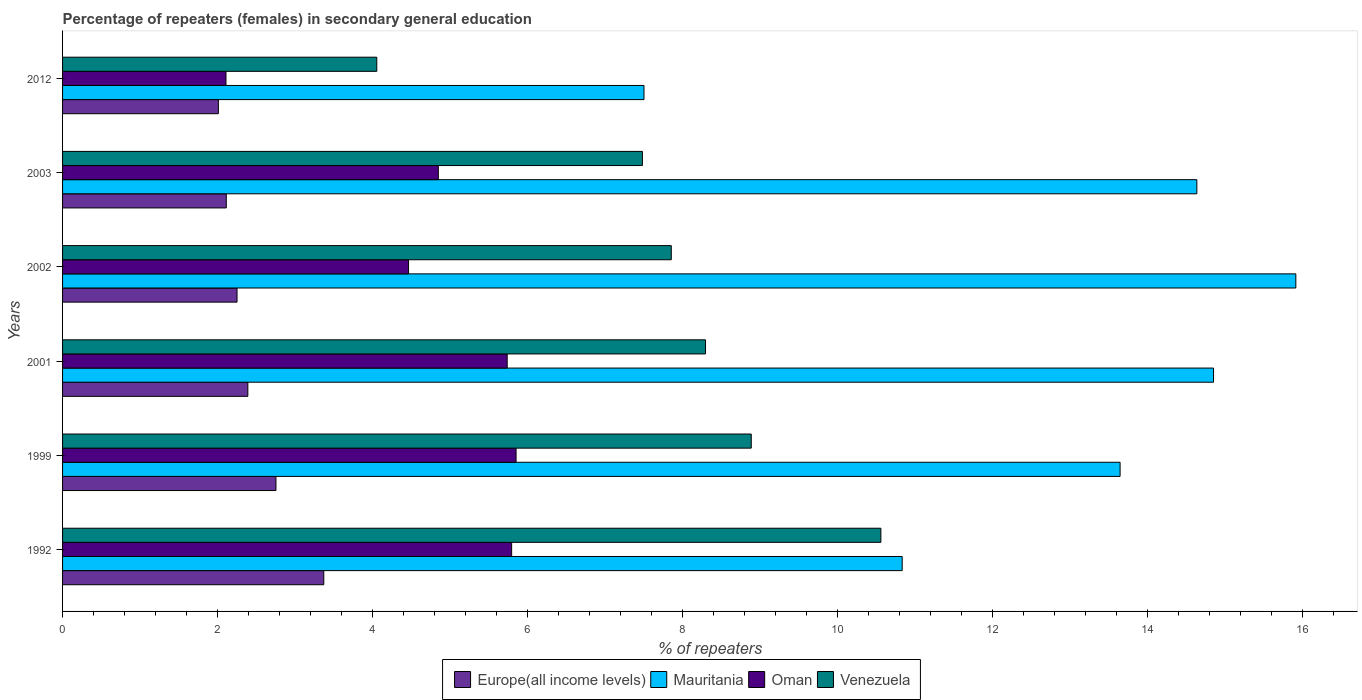How many different coloured bars are there?
Offer a very short reply. 4. How many bars are there on the 1st tick from the top?
Make the answer very short. 4. How many bars are there on the 5th tick from the bottom?
Provide a succinct answer. 4. What is the label of the 6th group of bars from the top?
Offer a very short reply. 1992. In how many cases, is the number of bars for a given year not equal to the number of legend labels?
Your answer should be compact. 0. What is the percentage of female repeaters in Venezuela in 1999?
Make the answer very short. 8.89. Across all years, what is the maximum percentage of female repeaters in Venezuela?
Your answer should be very brief. 10.56. Across all years, what is the minimum percentage of female repeaters in Europe(all income levels)?
Provide a succinct answer. 2.01. What is the total percentage of female repeaters in Europe(all income levels) in the graph?
Ensure brevity in your answer.  14.89. What is the difference between the percentage of female repeaters in Europe(all income levels) in 1992 and that in 2003?
Provide a short and direct response. 1.26. What is the difference between the percentage of female repeaters in Oman in 1992 and the percentage of female repeaters in Europe(all income levels) in 2012?
Your answer should be compact. 3.78. What is the average percentage of female repeaters in Mauritania per year?
Your response must be concise. 12.9. In the year 2003, what is the difference between the percentage of female repeaters in Europe(all income levels) and percentage of female repeaters in Venezuela?
Ensure brevity in your answer.  -5.37. What is the ratio of the percentage of female repeaters in Venezuela in 1992 to that in 2001?
Ensure brevity in your answer.  1.27. What is the difference between the highest and the second highest percentage of female repeaters in Oman?
Provide a succinct answer. 0.06. What is the difference between the highest and the lowest percentage of female repeaters in Oman?
Offer a very short reply. 3.74. Is the sum of the percentage of female repeaters in Oman in 2002 and 2012 greater than the maximum percentage of female repeaters in Venezuela across all years?
Your answer should be compact. No. Is it the case that in every year, the sum of the percentage of female repeaters in Oman and percentage of female repeaters in Mauritania is greater than the sum of percentage of female repeaters in Europe(all income levels) and percentage of female repeaters in Venezuela?
Offer a terse response. No. What does the 4th bar from the top in 1992 represents?
Provide a short and direct response. Europe(all income levels). What does the 3rd bar from the bottom in 1999 represents?
Provide a succinct answer. Oman. Are all the bars in the graph horizontal?
Give a very brief answer. Yes. What is the difference between two consecutive major ticks on the X-axis?
Offer a very short reply. 2. Are the values on the major ticks of X-axis written in scientific E-notation?
Your answer should be compact. No. Where does the legend appear in the graph?
Keep it short and to the point. Bottom center. What is the title of the graph?
Your answer should be compact. Percentage of repeaters (females) in secondary general education. What is the label or title of the X-axis?
Your answer should be very brief. % of repeaters. What is the label or title of the Y-axis?
Your answer should be very brief. Years. What is the % of repeaters of Europe(all income levels) in 1992?
Offer a very short reply. 3.37. What is the % of repeaters of Mauritania in 1992?
Offer a terse response. 10.83. What is the % of repeaters in Oman in 1992?
Give a very brief answer. 5.79. What is the % of repeaters of Venezuela in 1992?
Your answer should be compact. 10.56. What is the % of repeaters in Europe(all income levels) in 1999?
Your answer should be compact. 2.75. What is the % of repeaters of Mauritania in 1999?
Offer a very short reply. 13.64. What is the % of repeaters of Oman in 1999?
Offer a very short reply. 5.85. What is the % of repeaters in Venezuela in 1999?
Your response must be concise. 8.89. What is the % of repeaters of Europe(all income levels) in 2001?
Keep it short and to the point. 2.39. What is the % of repeaters in Mauritania in 2001?
Your response must be concise. 14.85. What is the % of repeaters in Oman in 2001?
Your answer should be very brief. 5.74. What is the % of repeaters of Venezuela in 2001?
Your answer should be compact. 8.3. What is the % of repeaters in Europe(all income levels) in 2002?
Your answer should be compact. 2.25. What is the % of repeaters of Mauritania in 2002?
Provide a short and direct response. 15.91. What is the % of repeaters in Oman in 2002?
Your answer should be very brief. 4.46. What is the % of repeaters in Venezuela in 2002?
Ensure brevity in your answer.  7.85. What is the % of repeaters of Europe(all income levels) in 2003?
Ensure brevity in your answer.  2.11. What is the % of repeaters of Mauritania in 2003?
Offer a terse response. 14.64. What is the % of repeaters in Oman in 2003?
Your answer should be compact. 4.85. What is the % of repeaters in Venezuela in 2003?
Give a very brief answer. 7.48. What is the % of repeaters in Europe(all income levels) in 2012?
Ensure brevity in your answer.  2.01. What is the % of repeaters of Mauritania in 2012?
Give a very brief answer. 7.5. What is the % of repeaters in Oman in 2012?
Give a very brief answer. 2.11. What is the % of repeaters in Venezuela in 2012?
Your answer should be very brief. 4.05. Across all years, what is the maximum % of repeaters of Europe(all income levels)?
Your answer should be very brief. 3.37. Across all years, what is the maximum % of repeaters of Mauritania?
Offer a terse response. 15.91. Across all years, what is the maximum % of repeaters of Oman?
Make the answer very short. 5.85. Across all years, what is the maximum % of repeaters of Venezuela?
Ensure brevity in your answer.  10.56. Across all years, what is the minimum % of repeaters of Europe(all income levels)?
Your answer should be compact. 2.01. Across all years, what is the minimum % of repeaters in Mauritania?
Make the answer very short. 7.5. Across all years, what is the minimum % of repeaters in Oman?
Your answer should be compact. 2.11. Across all years, what is the minimum % of repeaters in Venezuela?
Your response must be concise. 4.05. What is the total % of repeaters of Europe(all income levels) in the graph?
Keep it short and to the point. 14.89. What is the total % of repeaters of Mauritania in the graph?
Your response must be concise. 77.38. What is the total % of repeaters of Oman in the graph?
Make the answer very short. 28.8. What is the total % of repeaters in Venezuela in the graph?
Your response must be concise. 47.13. What is the difference between the % of repeaters of Europe(all income levels) in 1992 and that in 1999?
Make the answer very short. 0.62. What is the difference between the % of repeaters in Mauritania in 1992 and that in 1999?
Provide a short and direct response. -2.81. What is the difference between the % of repeaters of Oman in 1992 and that in 1999?
Offer a terse response. -0.06. What is the difference between the % of repeaters in Venezuela in 1992 and that in 1999?
Offer a very short reply. 1.67. What is the difference between the % of repeaters of Europe(all income levels) in 1992 and that in 2001?
Keep it short and to the point. 0.98. What is the difference between the % of repeaters in Mauritania in 1992 and that in 2001?
Offer a terse response. -4.02. What is the difference between the % of repeaters of Oman in 1992 and that in 2001?
Provide a short and direct response. 0.06. What is the difference between the % of repeaters of Venezuela in 1992 and that in 2001?
Offer a very short reply. 2.26. What is the difference between the % of repeaters in Europe(all income levels) in 1992 and that in 2002?
Ensure brevity in your answer.  1.12. What is the difference between the % of repeaters of Mauritania in 1992 and that in 2002?
Provide a succinct answer. -5.08. What is the difference between the % of repeaters in Oman in 1992 and that in 2002?
Your answer should be very brief. 1.33. What is the difference between the % of repeaters in Venezuela in 1992 and that in 2002?
Offer a very short reply. 2.7. What is the difference between the % of repeaters of Europe(all income levels) in 1992 and that in 2003?
Give a very brief answer. 1.26. What is the difference between the % of repeaters of Mauritania in 1992 and that in 2003?
Your response must be concise. -3.8. What is the difference between the % of repeaters of Oman in 1992 and that in 2003?
Offer a very short reply. 0.95. What is the difference between the % of repeaters of Venezuela in 1992 and that in 2003?
Provide a succinct answer. 3.08. What is the difference between the % of repeaters of Europe(all income levels) in 1992 and that in 2012?
Your answer should be very brief. 1.36. What is the difference between the % of repeaters of Mauritania in 1992 and that in 2012?
Offer a terse response. 3.33. What is the difference between the % of repeaters of Oman in 1992 and that in 2012?
Make the answer very short. 3.69. What is the difference between the % of repeaters in Venezuela in 1992 and that in 2012?
Keep it short and to the point. 6.5. What is the difference between the % of repeaters of Europe(all income levels) in 1999 and that in 2001?
Keep it short and to the point. 0.36. What is the difference between the % of repeaters of Mauritania in 1999 and that in 2001?
Keep it short and to the point. -1.21. What is the difference between the % of repeaters of Oman in 1999 and that in 2001?
Give a very brief answer. 0.11. What is the difference between the % of repeaters in Venezuela in 1999 and that in 2001?
Ensure brevity in your answer.  0.59. What is the difference between the % of repeaters in Europe(all income levels) in 1999 and that in 2002?
Make the answer very short. 0.5. What is the difference between the % of repeaters of Mauritania in 1999 and that in 2002?
Make the answer very short. -2.27. What is the difference between the % of repeaters of Oman in 1999 and that in 2002?
Make the answer very short. 1.39. What is the difference between the % of repeaters of Venezuela in 1999 and that in 2002?
Make the answer very short. 1.03. What is the difference between the % of repeaters in Europe(all income levels) in 1999 and that in 2003?
Provide a short and direct response. 0.64. What is the difference between the % of repeaters of Mauritania in 1999 and that in 2003?
Provide a short and direct response. -0.99. What is the difference between the % of repeaters of Oman in 1999 and that in 2003?
Offer a terse response. 1. What is the difference between the % of repeaters in Venezuela in 1999 and that in 2003?
Provide a short and direct response. 1.4. What is the difference between the % of repeaters of Europe(all income levels) in 1999 and that in 2012?
Provide a short and direct response. 0.74. What is the difference between the % of repeaters in Mauritania in 1999 and that in 2012?
Give a very brief answer. 6.14. What is the difference between the % of repeaters in Oman in 1999 and that in 2012?
Make the answer very short. 3.74. What is the difference between the % of repeaters of Venezuela in 1999 and that in 2012?
Your answer should be compact. 4.83. What is the difference between the % of repeaters of Europe(all income levels) in 2001 and that in 2002?
Provide a succinct answer. 0.14. What is the difference between the % of repeaters of Mauritania in 2001 and that in 2002?
Provide a succinct answer. -1.06. What is the difference between the % of repeaters of Oman in 2001 and that in 2002?
Provide a short and direct response. 1.27. What is the difference between the % of repeaters in Venezuela in 2001 and that in 2002?
Provide a succinct answer. 0.44. What is the difference between the % of repeaters in Europe(all income levels) in 2001 and that in 2003?
Provide a succinct answer. 0.28. What is the difference between the % of repeaters of Mauritania in 2001 and that in 2003?
Your answer should be very brief. 0.22. What is the difference between the % of repeaters in Oman in 2001 and that in 2003?
Provide a succinct answer. 0.89. What is the difference between the % of repeaters in Venezuela in 2001 and that in 2003?
Provide a succinct answer. 0.81. What is the difference between the % of repeaters of Europe(all income levels) in 2001 and that in 2012?
Your answer should be compact. 0.38. What is the difference between the % of repeaters of Mauritania in 2001 and that in 2012?
Keep it short and to the point. 7.35. What is the difference between the % of repeaters of Oman in 2001 and that in 2012?
Make the answer very short. 3.63. What is the difference between the % of repeaters of Venezuela in 2001 and that in 2012?
Provide a succinct answer. 4.24. What is the difference between the % of repeaters in Europe(all income levels) in 2002 and that in 2003?
Provide a succinct answer. 0.14. What is the difference between the % of repeaters of Mauritania in 2002 and that in 2003?
Offer a terse response. 1.28. What is the difference between the % of repeaters in Oman in 2002 and that in 2003?
Provide a succinct answer. -0.38. What is the difference between the % of repeaters of Venezuela in 2002 and that in 2003?
Provide a short and direct response. 0.37. What is the difference between the % of repeaters of Europe(all income levels) in 2002 and that in 2012?
Make the answer very short. 0.24. What is the difference between the % of repeaters in Mauritania in 2002 and that in 2012?
Provide a succinct answer. 8.41. What is the difference between the % of repeaters in Oman in 2002 and that in 2012?
Offer a very short reply. 2.36. What is the difference between the % of repeaters of Venezuela in 2002 and that in 2012?
Your response must be concise. 3.8. What is the difference between the % of repeaters in Europe(all income levels) in 2003 and that in 2012?
Your answer should be compact. 0.1. What is the difference between the % of repeaters of Mauritania in 2003 and that in 2012?
Provide a succinct answer. 7.13. What is the difference between the % of repeaters in Oman in 2003 and that in 2012?
Your answer should be compact. 2.74. What is the difference between the % of repeaters of Venezuela in 2003 and that in 2012?
Offer a terse response. 3.43. What is the difference between the % of repeaters in Europe(all income levels) in 1992 and the % of repeaters in Mauritania in 1999?
Offer a terse response. -10.27. What is the difference between the % of repeaters of Europe(all income levels) in 1992 and the % of repeaters of Oman in 1999?
Give a very brief answer. -2.48. What is the difference between the % of repeaters in Europe(all income levels) in 1992 and the % of repeaters in Venezuela in 1999?
Ensure brevity in your answer.  -5.52. What is the difference between the % of repeaters in Mauritania in 1992 and the % of repeaters in Oman in 1999?
Provide a short and direct response. 4.98. What is the difference between the % of repeaters in Mauritania in 1992 and the % of repeaters in Venezuela in 1999?
Provide a succinct answer. 1.95. What is the difference between the % of repeaters in Oman in 1992 and the % of repeaters in Venezuela in 1999?
Ensure brevity in your answer.  -3.09. What is the difference between the % of repeaters of Europe(all income levels) in 1992 and the % of repeaters of Mauritania in 2001?
Provide a succinct answer. -11.48. What is the difference between the % of repeaters of Europe(all income levels) in 1992 and the % of repeaters of Oman in 2001?
Provide a short and direct response. -2.37. What is the difference between the % of repeaters of Europe(all income levels) in 1992 and the % of repeaters of Venezuela in 2001?
Your response must be concise. -4.93. What is the difference between the % of repeaters of Mauritania in 1992 and the % of repeaters of Oman in 2001?
Ensure brevity in your answer.  5.1. What is the difference between the % of repeaters in Mauritania in 1992 and the % of repeaters in Venezuela in 2001?
Offer a terse response. 2.54. What is the difference between the % of repeaters in Oman in 1992 and the % of repeaters in Venezuela in 2001?
Ensure brevity in your answer.  -2.5. What is the difference between the % of repeaters in Europe(all income levels) in 1992 and the % of repeaters in Mauritania in 2002?
Provide a succinct answer. -12.54. What is the difference between the % of repeaters of Europe(all income levels) in 1992 and the % of repeaters of Oman in 2002?
Offer a very short reply. -1.09. What is the difference between the % of repeaters of Europe(all income levels) in 1992 and the % of repeaters of Venezuela in 2002?
Offer a very short reply. -4.48. What is the difference between the % of repeaters of Mauritania in 1992 and the % of repeaters of Oman in 2002?
Give a very brief answer. 6.37. What is the difference between the % of repeaters of Mauritania in 1992 and the % of repeaters of Venezuela in 2002?
Give a very brief answer. 2.98. What is the difference between the % of repeaters in Oman in 1992 and the % of repeaters in Venezuela in 2002?
Give a very brief answer. -2.06. What is the difference between the % of repeaters of Europe(all income levels) in 1992 and the % of repeaters of Mauritania in 2003?
Your answer should be very brief. -11.26. What is the difference between the % of repeaters of Europe(all income levels) in 1992 and the % of repeaters of Oman in 2003?
Offer a very short reply. -1.48. What is the difference between the % of repeaters in Europe(all income levels) in 1992 and the % of repeaters in Venezuela in 2003?
Keep it short and to the point. -4.11. What is the difference between the % of repeaters in Mauritania in 1992 and the % of repeaters in Oman in 2003?
Your answer should be very brief. 5.99. What is the difference between the % of repeaters of Mauritania in 1992 and the % of repeaters of Venezuela in 2003?
Provide a succinct answer. 3.35. What is the difference between the % of repeaters of Oman in 1992 and the % of repeaters of Venezuela in 2003?
Your response must be concise. -1.69. What is the difference between the % of repeaters in Europe(all income levels) in 1992 and the % of repeaters in Mauritania in 2012?
Keep it short and to the point. -4.13. What is the difference between the % of repeaters of Europe(all income levels) in 1992 and the % of repeaters of Oman in 2012?
Make the answer very short. 1.26. What is the difference between the % of repeaters in Europe(all income levels) in 1992 and the % of repeaters in Venezuela in 2012?
Your answer should be very brief. -0.68. What is the difference between the % of repeaters in Mauritania in 1992 and the % of repeaters in Oman in 2012?
Give a very brief answer. 8.72. What is the difference between the % of repeaters in Mauritania in 1992 and the % of repeaters in Venezuela in 2012?
Keep it short and to the point. 6.78. What is the difference between the % of repeaters of Oman in 1992 and the % of repeaters of Venezuela in 2012?
Provide a short and direct response. 1.74. What is the difference between the % of repeaters in Europe(all income levels) in 1999 and the % of repeaters in Mauritania in 2001?
Your answer should be compact. -12.1. What is the difference between the % of repeaters of Europe(all income levels) in 1999 and the % of repeaters of Oman in 2001?
Provide a short and direct response. -2.98. What is the difference between the % of repeaters of Europe(all income levels) in 1999 and the % of repeaters of Venezuela in 2001?
Offer a very short reply. -5.54. What is the difference between the % of repeaters of Mauritania in 1999 and the % of repeaters of Oman in 2001?
Give a very brief answer. 7.91. What is the difference between the % of repeaters of Mauritania in 1999 and the % of repeaters of Venezuela in 2001?
Offer a terse response. 5.35. What is the difference between the % of repeaters in Oman in 1999 and the % of repeaters in Venezuela in 2001?
Your answer should be very brief. -2.44. What is the difference between the % of repeaters of Europe(all income levels) in 1999 and the % of repeaters of Mauritania in 2002?
Provide a short and direct response. -13.16. What is the difference between the % of repeaters in Europe(all income levels) in 1999 and the % of repeaters in Oman in 2002?
Make the answer very short. -1.71. What is the difference between the % of repeaters in Europe(all income levels) in 1999 and the % of repeaters in Venezuela in 2002?
Offer a very short reply. -5.1. What is the difference between the % of repeaters in Mauritania in 1999 and the % of repeaters in Oman in 2002?
Your response must be concise. 9.18. What is the difference between the % of repeaters in Mauritania in 1999 and the % of repeaters in Venezuela in 2002?
Provide a short and direct response. 5.79. What is the difference between the % of repeaters of Oman in 1999 and the % of repeaters of Venezuela in 2002?
Give a very brief answer. -2. What is the difference between the % of repeaters of Europe(all income levels) in 1999 and the % of repeaters of Mauritania in 2003?
Your response must be concise. -11.88. What is the difference between the % of repeaters in Europe(all income levels) in 1999 and the % of repeaters in Oman in 2003?
Your answer should be very brief. -2.1. What is the difference between the % of repeaters of Europe(all income levels) in 1999 and the % of repeaters of Venezuela in 2003?
Provide a succinct answer. -4.73. What is the difference between the % of repeaters of Mauritania in 1999 and the % of repeaters of Oman in 2003?
Your answer should be very brief. 8.8. What is the difference between the % of repeaters of Mauritania in 1999 and the % of repeaters of Venezuela in 2003?
Give a very brief answer. 6.16. What is the difference between the % of repeaters in Oman in 1999 and the % of repeaters in Venezuela in 2003?
Give a very brief answer. -1.63. What is the difference between the % of repeaters of Europe(all income levels) in 1999 and the % of repeaters of Mauritania in 2012?
Give a very brief answer. -4.75. What is the difference between the % of repeaters in Europe(all income levels) in 1999 and the % of repeaters in Oman in 2012?
Offer a very short reply. 0.64. What is the difference between the % of repeaters of Europe(all income levels) in 1999 and the % of repeaters of Venezuela in 2012?
Keep it short and to the point. -1.3. What is the difference between the % of repeaters in Mauritania in 1999 and the % of repeaters in Oman in 2012?
Offer a very short reply. 11.54. What is the difference between the % of repeaters of Mauritania in 1999 and the % of repeaters of Venezuela in 2012?
Make the answer very short. 9.59. What is the difference between the % of repeaters of Oman in 1999 and the % of repeaters of Venezuela in 2012?
Your answer should be very brief. 1.8. What is the difference between the % of repeaters in Europe(all income levels) in 2001 and the % of repeaters in Mauritania in 2002?
Your answer should be compact. -13.52. What is the difference between the % of repeaters of Europe(all income levels) in 2001 and the % of repeaters of Oman in 2002?
Give a very brief answer. -2.07. What is the difference between the % of repeaters of Europe(all income levels) in 2001 and the % of repeaters of Venezuela in 2002?
Your response must be concise. -5.46. What is the difference between the % of repeaters in Mauritania in 2001 and the % of repeaters in Oman in 2002?
Make the answer very short. 10.39. What is the difference between the % of repeaters in Mauritania in 2001 and the % of repeaters in Venezuela in 2002?
Offer a terse response. 7. What is the difference between the % of repeaters in Oman in 2001 and the % of repeaters in Venezuela in 2002?
Your answer should be very brief. -2.12. What is the difference between the % of repeaters in Europe(all income levels) in 2001 and the % of repeaters in Mauritania in 2003?
Ensure brevity in your answer.  -12.24. What is the difference between the % of repeaters in Europe(all income levels) in 2001 and the % of repeaters in Oman in 2003?
Give a very brief answer. -2.46. What is the difference between the % of repeaters in Europe(all income levels) in 2001 and the % of repeaters in Venezuela in 2003?
Make the answer very short. -5.09. What is the difference between the % of repeaters of Mauritania in 2001 and the % of repeaters of Oman in 2003?
Provide a succinct answer. 10. What is the difference between the % of repeaters in Mauritania in 2001 and the % of repeaters in Venezuela in 2003?
Give a very brief answer. 7.37. What is the difference between the % of repeaters in Oman in 2001 and the % of repeaters in Venezuela in 2003?
Offer a very short reply. -1.74. What is the difference between the % of repeaters in Europe(all income levels) in 2001 and the % of repeaters in Mauritania in 2012?
Make the answer very short. -5.11. What is the difference between the % of repeaters of Europe(all income levels) in 2001 and the % of repeaters of Oman in 2012?
Your answer should be very brief. 0.28. What is the difference between the % of repeaters in Europe(all income levels) in 2001 and the % of repeaters in Venezuela in 2012?
Offer a terse response. -1.66. What is the difference between the % of repeaters of Mauritania in 2001 and the % of repeaters of Oman in 2012?
Ensure brevity in your answer.  12.74. What is the difference between the % of repeaters in Mauritania in 2001 and the % of repeaters in Venezuela in 2012?
Offer a very short reply. 10.8. What is the difference between the % of repeaters in Oman in 2001 and the % of repeaters in Venezuela in 2012?
Your answer should be compact. 1.68. What is the difference between the % of repeaters in Europe(all income levels) in 2002 and the % of repeaters in Mauritania in 2003?
Offer a very short reply. -12.38. What is the difference between the % of repeaters in Europe(all income levels) in 2002 and the % of repeaters in Oman in 2003?
Ensure brevity in your answer.  -2.6. What is the difference between the % of repeaters in Europe(all income levels) in 2002 and the % of repeaters in Venezuela in 2003?
Keep it short and to the point. -5.23. What is the difference between the % of repeaters of Mauritania in 2002 and the % of repeaters of Oman in 2003?
Ensure brevity in your answer.  11.06. What is the difference between the % of repeaters of Mauritania in 2002 and the % of repeaters of Venezuela in 2003?
Provide a short and direct response. 8.43. What is the difference between the % of repeaters in Oman in 2002 and the % of repeaters in Venezuela in 2003?
Your answer should be compact. -3.02. What is the difference between the % of repeaters in Europe(all income levels) in 2002 and the % of repeaters in Mauritania in 2012?
Your answer should be very brief. -5.25. What is the difference between the % of repeaters of Europe(all income levels) in 2002 and the % of repeaters of Oman in 2012?
Give a very brief answer. 0.14. What is the difference between the % of repeaters of Europe(all income levels) in 2002 and the % of repeaters of Venezuela in 2012?
Provide a succinct answer. -1.8. What is the difference between the % of repeaters in Mauritania in 2002 and the % of repeaters in Oman in 2012?
Keep it short and to the point. 13.8. What is the difference between the % of repeaters of Mauritania in 2002 and the % of repeaters of Venezuela in 2012?
Offer a terse response. 11.86. What is the difference between the % of repeaters in Oman in 2002 and the % of repeaters in Venezuela in 2012?
Your response must be concise. 0.41. What is the difference between the % of repeaters of Europe(all income levels) in 2003 and the % of repeaters of Mauritania in 2012?
Provide a succinct answer. -5.39. What is the difference between the % of repeaters of Europe(all income levels) in 2003 and the % of repeaters of Oman in 2012?
Provide a short and direct response. 0. What is the difference between the % of repeaters of Europe(all income levels) in 2003 and the % of repeaters of Venezuela in 2012?
Provide a succinct answer. -1.94. What is the difference between the % of repeaters in Mauritania in 2003 and the % of repeaters in Oman in 2012?
Offer a very short reply. 12.53. What is the difference between the % of repeaters of Mauritania in 2003 and the % of repeaters of Venezuela in 2012?
Your response must be concise. 10.58. What is the difference between the % of repeaters of Oman in 2003 and the % of repeaters of Venezuela in 2012?
Make the answer very short. 0.79. What is the average % of repeaters of Europe(all income levels) per year?
Your response must be concise. 2.48. What is the average % of repeaters of Mauritania per year?
Ensure brevity in your answer.  12.9. What is the average % of repeaters in Oman per year?
Your answer should be very brief. 4.8. What is the average % of repeaters in Venezuela per year?
Your response must be concise. 7.86. In the year 1992, what is the difference between the % of repeaters in Europe(all income levels) and % of repeaters in Mauritania?
Your answer should be very brief. -7.46. In the year 1992, what is the difference between the % of repeaters in Europe(all income levels) and % of repeaters in Oman?
Make the answer very short. -2.42. In the year 1992, what is the difference between the % of repeaters of Europe(all income levels) and % of repeaters of Venezuela?
Provide a succinct answer. -7.19. In the year 1992, what is the difference between the % of repeaters of Mauritania and % of repeaters of Oman?
Give a very brief answer. 5.04. In the year 1992, what is the difference between the % of repeaters of Mauritania and % of repeaters of Venezuela?
Provide a short and direct response. 0.28. In the year 1992, what is the difference between the % of repeaters in Oman and % of repeaters in Venezuela?
Provide a short and direct response. -4.76. In the year 1999, what is the difference between the % of repeaters of Europe(all income levels) and % of repeaters of Mauritania?
Provide a succinct answer. -10.89. In the year 1999, what is the difference between the % of repeaters of Europe(all income levels) and % of repeaters of Oman?
Provide a short and direct response. -3.1. In the year 1999, what is the difference between the % of repeaters of Europe(all income levels) and % of repeaters of Venezuela?
Give a very brief answer. -6.13. In the year 1999, what is the difference between the % of repeaters of Mauritania and % of repeaters of Oman?
Your answer should be very brief. 7.79. In the year 1999, what is the difference between the % of repeaters of Mauritania and % of repeaters of Venezuela?
Your response must be concise. 4.76. In the year 1999, what is the difference between the % of repeaters of Oman and % of repeaters of Venezuela?
Keep it short and to the point. -3.03. In the year 2001, what is the difference between the % of repeaters of Europe(all income levels) and % of repeaters of Mauritania?
Provide a succinct answer. -12.46. In the year 2001, what is the difference between the % of repeaters in Europe(all income levels) and % of repeaters in Oman?
Ensure brevity in your answer.  -3.35. In the year 2001, what is the difference between the % of repeaters of Europe(all income levels) and % of repeaters of Venezuela?
Provide a short and direct response. -5.91. In the year 2001, what is the difference between the % of repeaters of Mauritania and % of repeaters of Oman?
Keep it short and to the point. 9.11. In the year 2001, what is the difference between the % of repeaters in Mauritania and % of repeaters in Venezuela?
Offer a very short reply. 6.55. In the year 2001, what is the difference between the % of repeaters in Oman and % of repeaters in Venezuela?
Keep it short and to the point. -2.56. In the year 2002, what is the difference between the % of repeaters of Europe(all income levels) and % of repeaters of Mauritania?
Your answer should be very brief. -13.66. In the year 2002, what is the difference between the % of repeaters in Europe(all income levels) and % of repeaters in Oman?
Your answer should be compact. -2.21. In the year 2002, what is the difference between the % of repeaters in Europe(all income levels) and % of repeaters in Venezuela?
Keep it short and to the point. -5.6. In the year 2002, what is the difference between the % of repeaters of Mauritania and % of repeaters of Oman?
Ensure brevity in your answer.  11.45. In the year 2002, what is the difference between the % of repeaters of Mauritania and % of repeaters of Venezuela?
Give a very brief answer. 8.06. In the year 2002, what is the difference between the % of repeaters in Oman and % of repeaters in Venezuela?
Ensure brevity in your answer.  -3.39. In the year 2003, what is the difference between the % of repeaters in Europe(all income levels) and % of repeaters in Mauritania?
Provide a succinct answer. -12.52. In the year 2003, what is the difference between the % of repeaters of Europe(all income levels) and % of repeaters of Oman?
Provide a succinct answer. -2.74. In the year 2003, what is the difference between the % of repeaters in Europe(all income levels) and % of repeaters in Venezuela?
Offer a very short reply. -5.37. In the year 2003, what is the difference between the % of repeaters in Mauritania and % of repeaters in Oman?
Ensure brevity in your answer.  9.79. In the year 2003, what is the difference between the % of repeaters in Mauritania and % of repeaters in Venezuela?
Offer a terse response. 7.15. In the year 2003, what is the difference between the % of repeaters in Oman and % of repeaters in Venezuela?
Offer a terse response. -2.63. In the year 2012, what is the difference between the % of repeaters of Europe(all income levels) and % of repeaters of Mauritania?
Provide a succinct answer. -5.49. In the year 2012, what is the difference between the % of repeaters in Europe(all income levels) and % of repeaters in Oman?
Your response must be concise. -0.1. In the year 2012, what is the difference between the % of repeaters of Europe(all income levels) and % of repeaters of Venezuela?
Your answer should be compact. -2.04. In the year 2012, what is the difference between the % of repeaters in Mauritania and % of repeaters in Oman?
Offer a terse response. 5.39. In the year 2012, what is the difference between the % of repeaters in Mauritania and % of repeaters in Venezuela?
Give a very brief answer. 3.45. In the year 2012, what is the difference between the % of repeaters in Oman and % of repeaters in Venezuela?
Your answer should be very brief. -1.95. What is the ratio of the % of repeaters in Europe(all income levels) in 1992 to that in 1999?
Keep it short and to the point. 1.22. What is the ratio of the % of repeaters of Mauritania in 1992 to that in 1999?
Offer a terse response. 0.79. What is the ratio of the % of repeaters in Oman in 1992 to that in 1999?
Ensure brevity in your answer.  0.99. What is the ratio of the % of repeaters of Venezuela in 1992 to that in 1999?
Make the answer very short. 1.19. What is the ratio of the % of repeaters in Europe(all income levels) in 1992 to that in 2001?
Ensure brevity in your answer.  1.41. What is the ratio of the % of repeaters of Mauritania in 1992 to that in 2001?
Give a very brief answer. 0.73. What is the ratio of the % of repeaters in Oman in 1992 to that in 2001?
Offer a very short reply. 1.01. What is the ratio of the % of repeaters in Venezuela in 1992 to that in 2001?
Offer a terse response. 1.27. What is the ratio of the % of repeaters in Europe(all income levels) in 1992 to that in 2002?
Make the answer very short. 1.5. What is the ratio of the % of repeaters of Mauritania in 1992 to that in 2002?
Your answer should be compact. 0.68. What is the ratio of the % of repeaters in Oman in 1992 to that in 2002?
Ensure brevity in your answer.  1.3. What is the ratio of the % of repeaters in Venezuela in 1992 to that in 2002?
Provide a succinct answer. 1.34. What is the ratio of the % of repeaters of Europe(all income levels) in 1992 to that in 2003?
Provide a succinct answer. 1.6. What is the ratio of the % of repeaters of Mauritania in 1992 to that in 2003?
Ensure brevity in your answer.  0.74. What is the ratio of the % of repeaters of Oman in 1992 to that in 2003?
Your response must be concise. 1.2. What is the ratio of the % of repeaters of Venezuela in 1992 to that in 2003?
Provide a succinct answer. 1.41. What is the ratio of the % of repeaters of Europe(all income levels) in 1992 to that in 2012?
Provide a short and direct response. 1.68. What is the ratio of the % of repeaters in Mauritania in 1992 to that in 2012?
Give a very brief answer. 1.44. What is the ratio of the % of repeaters in Oman in 1992 to that in 2012?
Provide a succinct answer. 2.75. What is the ratio of the % of repeaters in Venezuela in 1992 to that in 2012?
Make the answer very short. 2.6. What is the ratio of the % of repeaters of Europe(all income levels) in 1999 to that in 2001?
Your response must be concise. 1.15. What is the ratio of the % of repeaters of Mauritania in 1999 to that in 2001?
Your answer should be compact. 0.92. What is the ratio of the % of repeaters in Oman in 1999 to that in 2001?
Provide a succinct answer. 1.02. What is the ratio of the % of repeaters of Venezuela in 1999 to that in 2001?
Give a very brief answer. 1.07. What is the ratio of the % of repeaters in Europe(all income levels) in 1999 to that in 2002?
Provide a short and direct response. 1.22. What is the ratio of the % of repeaters in Mauritania in 1999 to that in 2002?
Make the answer very short. 0.86. What is the ratio of the % of repeaters of Oman in 1999 to that in 2002?
Provide a short and direct response. 1.31. What is the ratio of the % of repeaters of Venezuela in 1999 to that in 2002?
Your answer should be very brief. 1.13. What is the ratio of the % of repeaters of Europe(all income levels) in 1999 to that in 2003?
Offer a very short reply. 1.3. What is the ratio of the % of repeaters of Mauritania in 1999 to that in 2003?
Ensure brevity in your answer.  0.93. What is the ratio of the % of repeaters in Oman in 1999 to that in 2003?
Offer a very short reply. 1.21. What is the ratio of the % of repeaters in Venezuela in 1999 to that in 2003?
Offer a terse response. 1.19. What is the ratio of the % of repeaters in Europe(all income levels) in 1999 to that in 2012?
Offer a very short reply. 1.37. What is the ratio of the % of repeaters in Mauritania in 1999 to that in 2012?
Provide a short and direct response. 1.82. What is the ratio of the % of repeaters in Oman in 1999 to that in 2012?
Your answer should be very brief. 2.78. What is the ratio of the % of repeaters in Venezuela in 1999 to that in 2012?
Your response must be concise. 2.19. What is the ratio of the % of repeaters of Europe(all income levels) in 2001 to that in 2002?
Your answer should be very brief. 1.06. What is the ratio of the % of repeaters in Oman in 2001 to that in 2002?
Offer a terse response. 1.29. What is the ratio of the % of repeaters of Venezuela in 2001 to that in 2002?
Your answer should be very brief. 1.06. What is the ratio of the % of repeaters of Europe(all income levels) in 2001 to that in 2003?
Provide a succinct answer. 1.13. What is the ratio of the % of repeaters in Mauritania in 2001 to that in 2003?
Keep it short and to the point. 1.01. What is the ratio of the % of repeaters in Oman in 2001 to that in 2003?
Your response must be concise. 1.18. What is the ratio of the % of repeaters in Venezuela in 2001 to that in 2003?
Provide a short and direct response. 1.11. What is the ratio of the % of repeaters in Europe(all income levels) in 2001 to that in 2012?
Your answer should be very brief. 1.19. What is the ratio of the % of repeaters in Mauritania in 2001 to that in 2012?
Provide a short and direct response. 1.98. What is the ratio of the % of repeaters of Oman in 2001 to that in 2012?
Keep it short and to the point. 2.72. What is the ratio of the % of repeaters of Venezuela in 2001 to that in 2012?
Keep it short and to the point. 2.05. What is the ratio of the % of repeaters in Europe(all income levels) in 2002 to that in 2003?
Offer a terse response. 1.07. What is the ratio of the % of repeaters of Mauritania in 2002 to that in 2003?
Provide a succinct answer. 1.09. What is the ratio of the % of repeaters in Oman in 2002 to that in 2003?
Give a very brief answer. 0.92. What is the ratio of the % of repeaters of Venezuela in 2002 to that in 2003?
Your response must be concise. 1.05. What is the ratio of the % of repeaters in Europe(all income levels) in 2002 to that in 2012?
Your answer should be very brief. 1.12. What is the ratio of the % of repeaters of Mauritania in 2002 to that in 2012?
Your answer should be very brief. 2.12. What is the ratio of the % of repeaters of Oman in 2002 to that in 2012?
Your answer should be very brief. 2.12. What is the ratio of the % of repeaters in Venezuela in 2002 to that in 2012?
Provide a succinct answer. 1.94. What is the ratio of the % of repeaters in Europe(all income levels) in 2003 to that in 2012?
Make the answer very short. 1.05. What is the ratio of the % of repeaters in Mauritania in 2003 to that in 2012?
Keep it short and to the point. 1.95. What is the ratio of the % of repeaters of Oman in 2003 to that in 2012?
Ensure brevity in your answer.  2.3. What is the ratio of the % of repeaters of Venezuela in 2003 to that in 2012?
Your answer should be compact. 1.85. What is the difference between the highest and the second highest % of repeaters of Europe(all income levels)?
Make the answer very short. 0.62. What is the difference between the highest and the second highest % of repeaters of Mauritania?
Offer a terse response. 1.06. What is the difference between the highest and the second highest % of repeaters in Oman?
Your answer should be compact. 0.06. What is the difference between the highest and the second highest % of repeaters in Venezuela?
Provide a succinct answer. 1.67. What is the difference between the highest and the lowest % of repeaters of Europe(all income levels)?
Keep it short and to the point. 1.36. What is the difference between the highest and the lowest % of repeaters of Mauritania?
Your answer should be very brief. 8.41. What is the difference between the highest and the lowest % of repeaters in Oman?
Keep it short and to the point. 3.74. What is the difference between the highest and the lowest % of repeaters of Venezuela?
Provide a short and direct response. 6.5. 